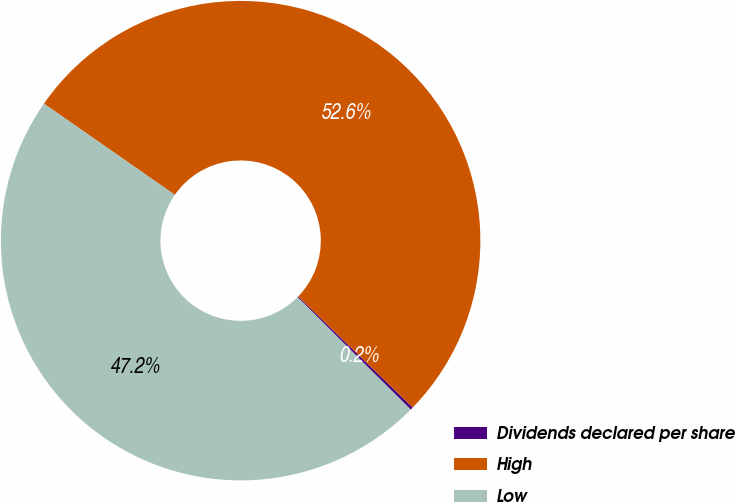Convert chart. <chart><loc_0><loc_0><loc_500><loc_500><pie_chart><fcel>Dividends declared per share<fcel>High<fcel>Low<nl><fcel>0.2%<fcel>52.57%<fcel>47.23%<nl></chart> 